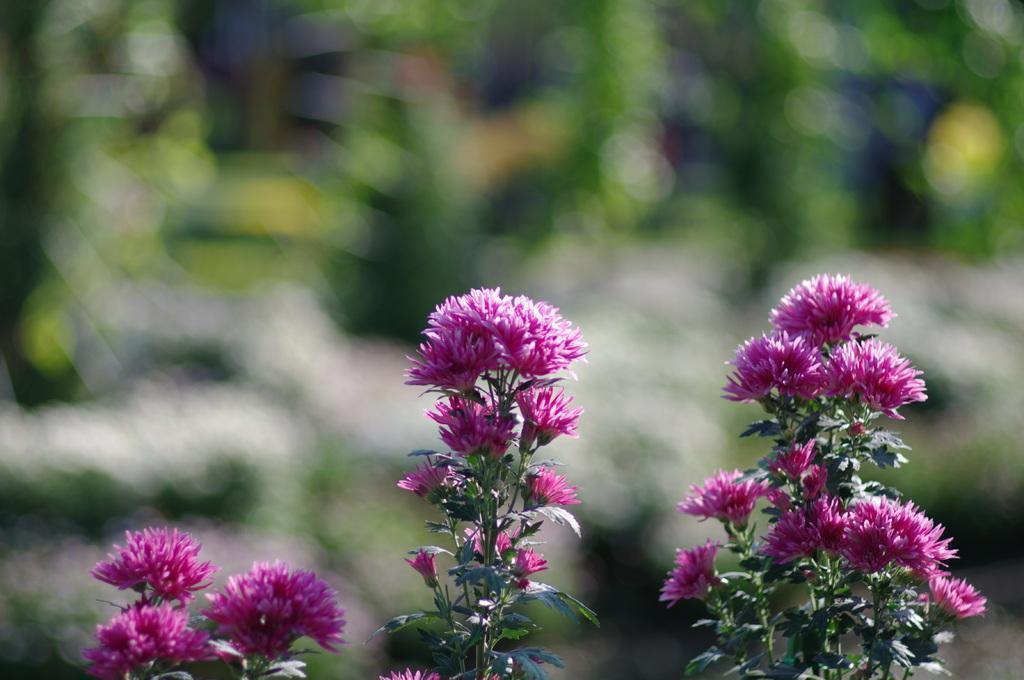Could you give a brief overview of what you see in this image? Here we can see flowers and leaves. There is a blur background with greenery. 